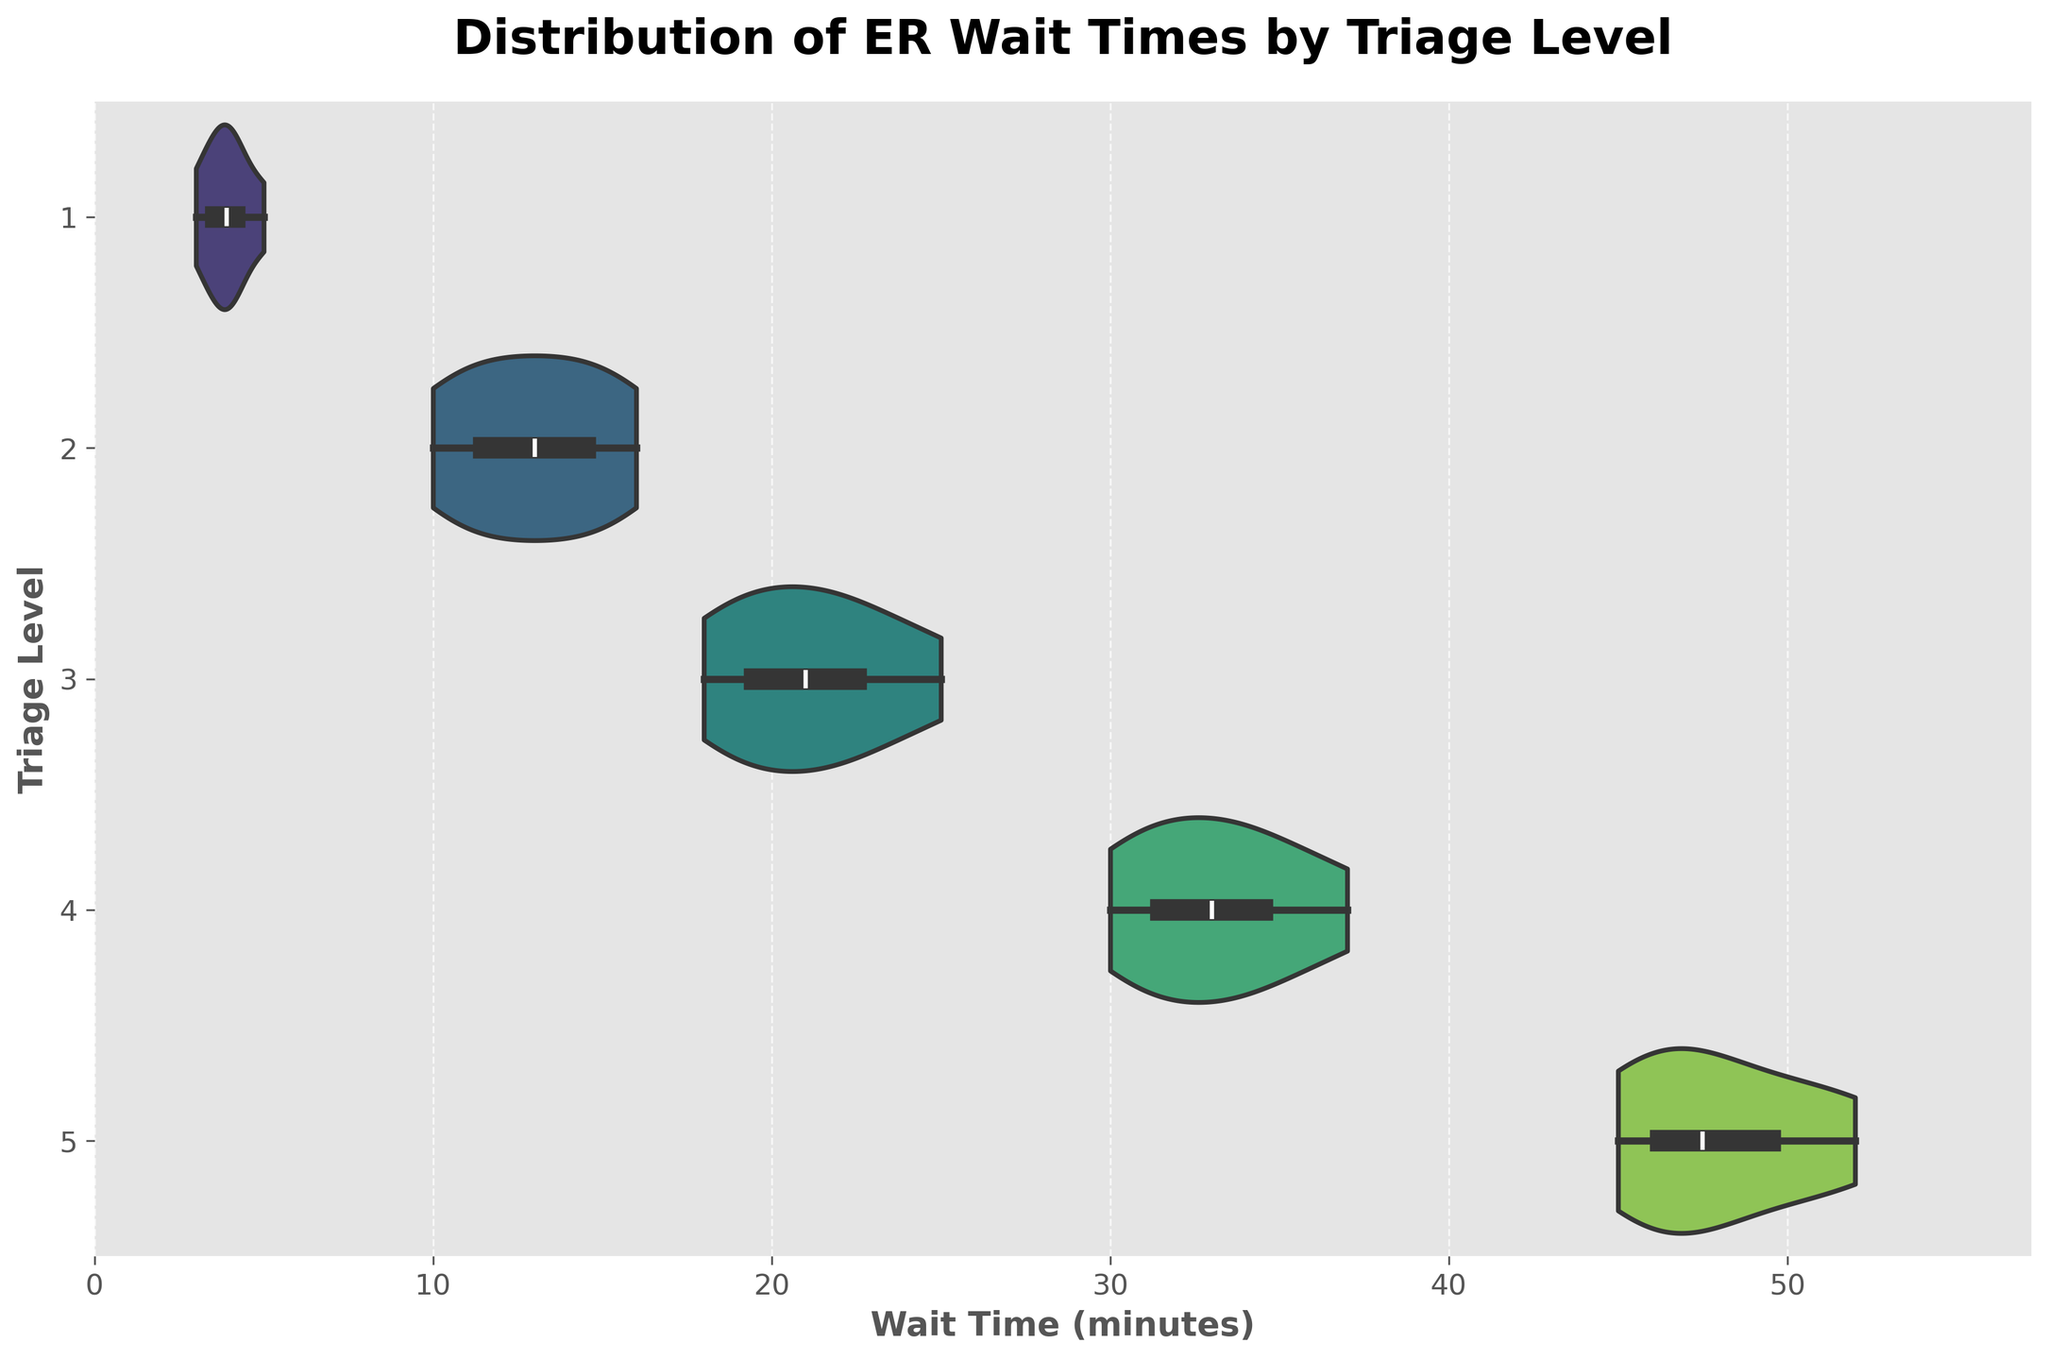What is the title of the figure? The title of the figure is typically displayed at the top and gives an overview of what the chart is about. Look at the top center of the plot to find the title.
Answer: Distribution of ER Wait Times by Triage Level How many different Triage Levels are represented in the figure? The Triage Levels are listed on the y-axis of the figure. Count the distinct values listed along the y-axis.
Answer: 5 What does the x-axis represent in the figure? The x-axis label typically provides information on what the horizontal axis measures. Look for the label adjacent to the x-axis.
Answer: Wait Time (minutes) Which Triage Level has the shortest median wait time? The median wait time is shown by the white dot within each violin plot. Locate the Triage Level with the lowest position of the white dot on the x-axis.
Answer: 1 What is the approximate median wait time for Triage Level 3? Find the white dot within the violin plot for Triage Level 3 and approximate its position along the x-axis.
Answer: 21 minutes Which Triage Level has the widest range of wait times? The range of wait times is indicated by the extent of the violin plot along the x-axis. Identify the Triage Level with the widest horizontal spread.
Answer: 3 Compare the median wait times between Triage Level 2 and Triage Level 4. Which one is higher? Compare the position of the white dots within the violin plots for Triage Levels 2 and 4. The one with the dot further to the right has the higher median wait time.
Answer: Triage Level 4 Is the distribution of wait times for Triage Level 5 skewed or symmetric? Look at the shape of the violin plot for Triage Level 5. If the plot extends more to one side (left or right), it is skewed. If it is balanced, it is symmetric.
Answer: Skewed Which Triage Level shows the most variation around the mean wait time? Look for the violin plot with the largest spread around its mean, indicated by the white box.
Answer: Triage Level 3 How does the maximum wait time for Triage Level 1 compare to the median wait time for Triage Level 5? Identify the rightmost extent of the violin plot for Triage Level 1 (maximum wait time) and the white dot position for Triage Level 5 (median wait time). Compare their positions on the x-axis.
Answer: Maximum wait time for Triage Level 1 is less than the median wait time for Triage Level 5 